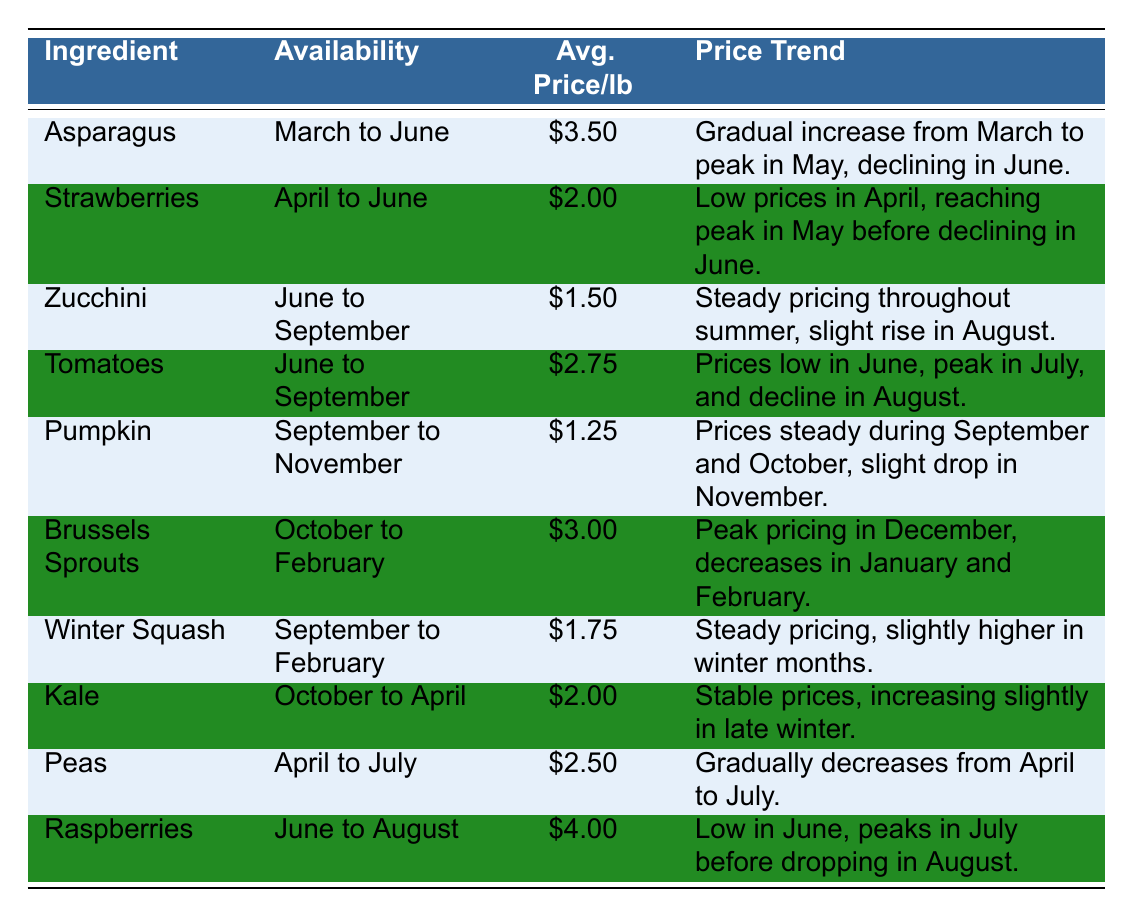What are the average prices for strawberries? The table lists the average price per pound for strawberries as $2.00.
Answer: $2.00 During which months are asparagus available? The availability of asparagus is noted in the table as from March to June.
Answer: March to June Which ingredient has the highest average price per pound? By comparing the prices in the table, raspberries have the highest average price at $4.00 per pound.
Answer: Raspberries Are pumpkin prices expected to increase in November? The table indicates that pumpkin prices are steady in September and October and then drop in November, suggesting no increase.
Answer: No What is the price trend for zucchini throughout its availability? The table describes zucchini's price trend as steady throughout summer with a slight rise in August.
Answer: Steady with a slight rise in August Which two ingredients have overlapping availability months? Both peas and strawberries are available overlapping from April to June based on the table entries.
Answer: Peas and strawberries What is the average price per pound of kale and Brussels sprouts combined? The average price for kale is $2.00 and for Brussels sprouts is $3.00. The combined price is $2.00 + $3.00 = $5.00. The average is $5.00 / 2 = $2.50.
Answer: $2.50 In which month do tomatoes reach their peak price? The table indicates that tomato prices reach their peak in July.
Answer: July Is the price of raspberries lower in June than April? The table does not specify the price for raspberries in April, but it indicates that prices are low in June, thus the comparison cannot be made from the provided information.
Answer: Insufficient information What is the trend of pea prices from April to July? The table notes that pea prices gradually decrease from April to July, indicating a downward trend.
Answer: Decrease 